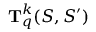<formula> <loc_0><loc_0><loc_500><loc_500>T _ { q } ^ { k } ( S , S ^ { \prime } )</formula> 